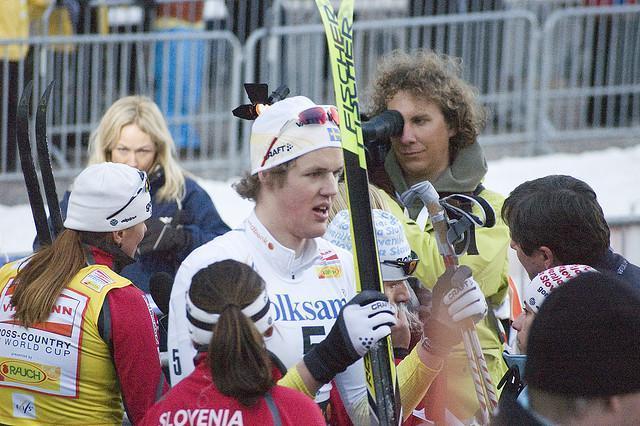How many ski can you see?
Give a very brief answer. 2. How many people can be seen?
Give a very brief answer. 9. 